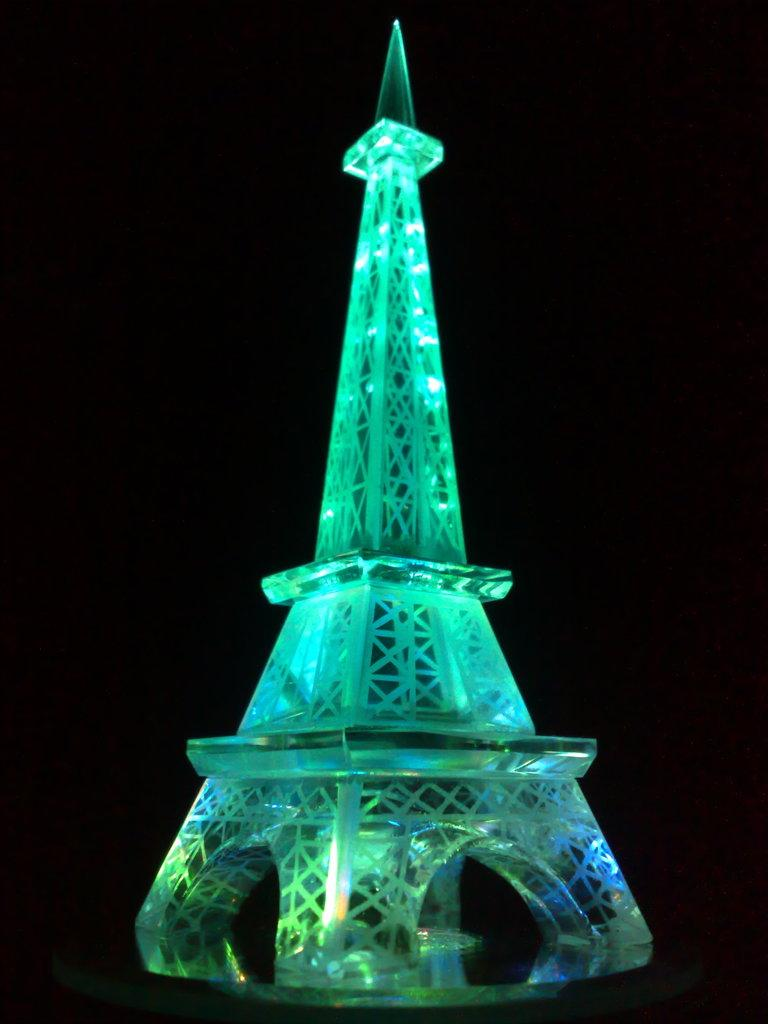What is the main subject of the image? The main subject of the image is a toy tower. What feature does the toy tower have? The toy tower has lights. How would you describe the overall appearance of the image? The background of the image is dark. What type of idea can be seen written on the sheet in the image? There is no sheet present in the image, so it is not possible to answer that question. 